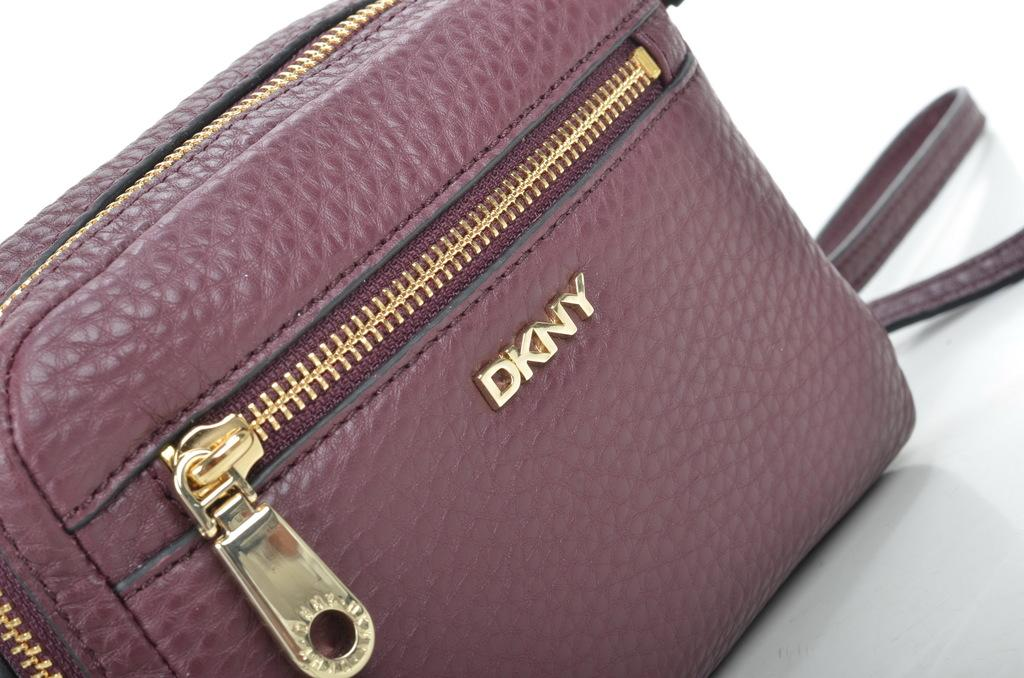What color is the bag in the image? The bag is in purple color. What is the color of the zip on the bag? The zip of the bag is in golden color. What brand name is written on the bag? The bag has "dkny" written on it. What type of hydrant can be seen near the bag in the image? There is no hydrant present in the image. What boundaries are visible around the bag in the image? The image does not show any boundaries around the bag. 